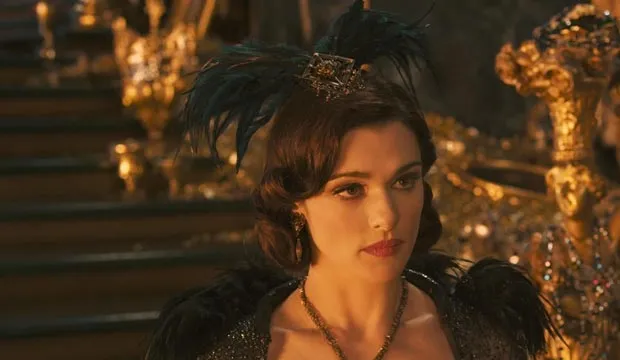Can you describe the main features of this image for me? In this mesmerizing scene, we are drawn into the world of 'Oz the Great and Powerful,' where the actress Rachel Weisz portrays the enigmatic character Evanora. She stands with dignified elegance in front of an opulent golden throne. Her costume is a striking ensemble of black and gold, featuring a dramatic black feathered headpiece adorned with a gold crown that enhances her regal appearance. The black and gold dress she wears flows gracefully, accentuating her commanding presence. Her eyes are slightly averted, and her serious expression suggests the unfolding of a significant moment within the story, adding to the image's overall intrigue and mystique. 